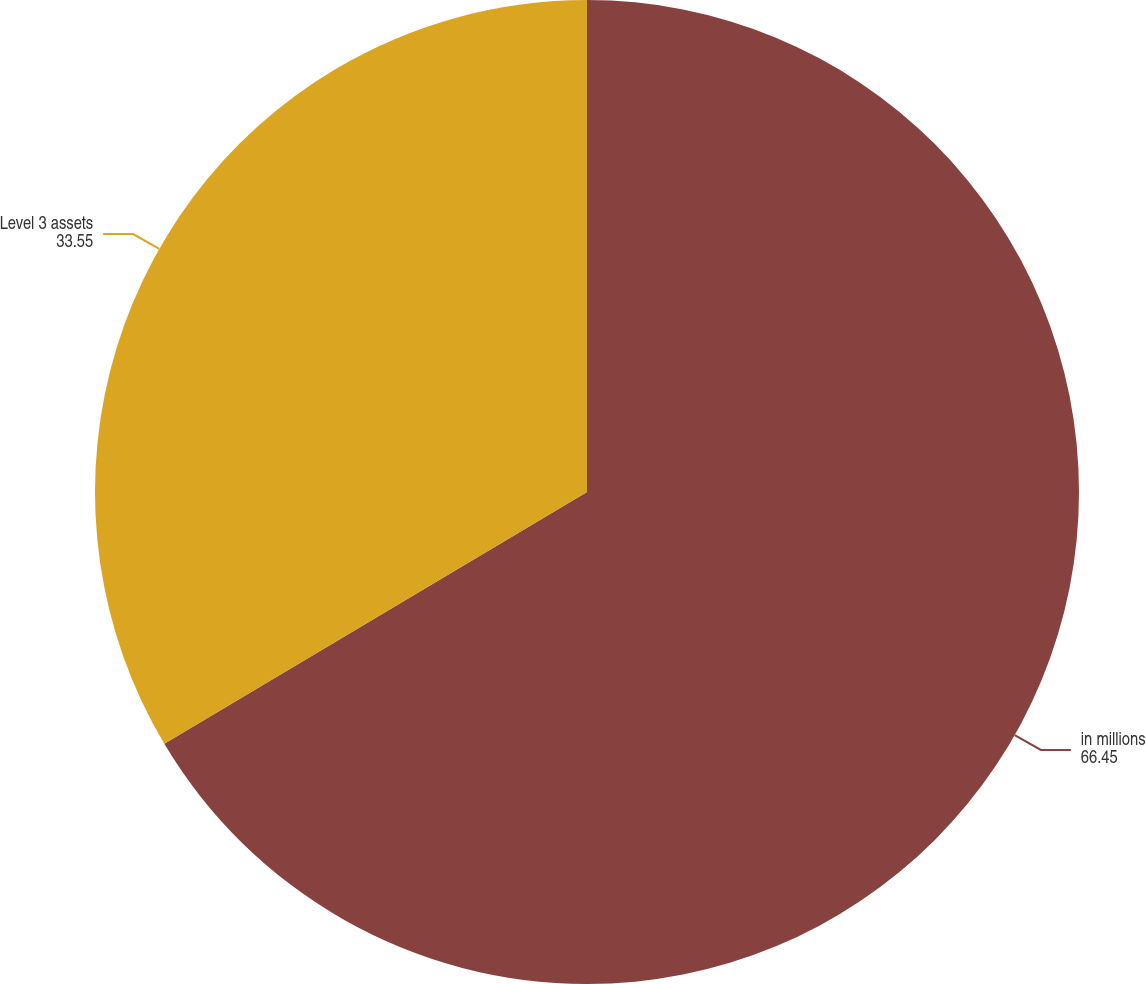Convert chart. <chart><loc_0><loc_0><loc_500><loc_500><pie_chart><fcel>in millions<fcel>Level 3 assets<nl><fcel>66.45%<fcel>33.55%<nl></chart> 